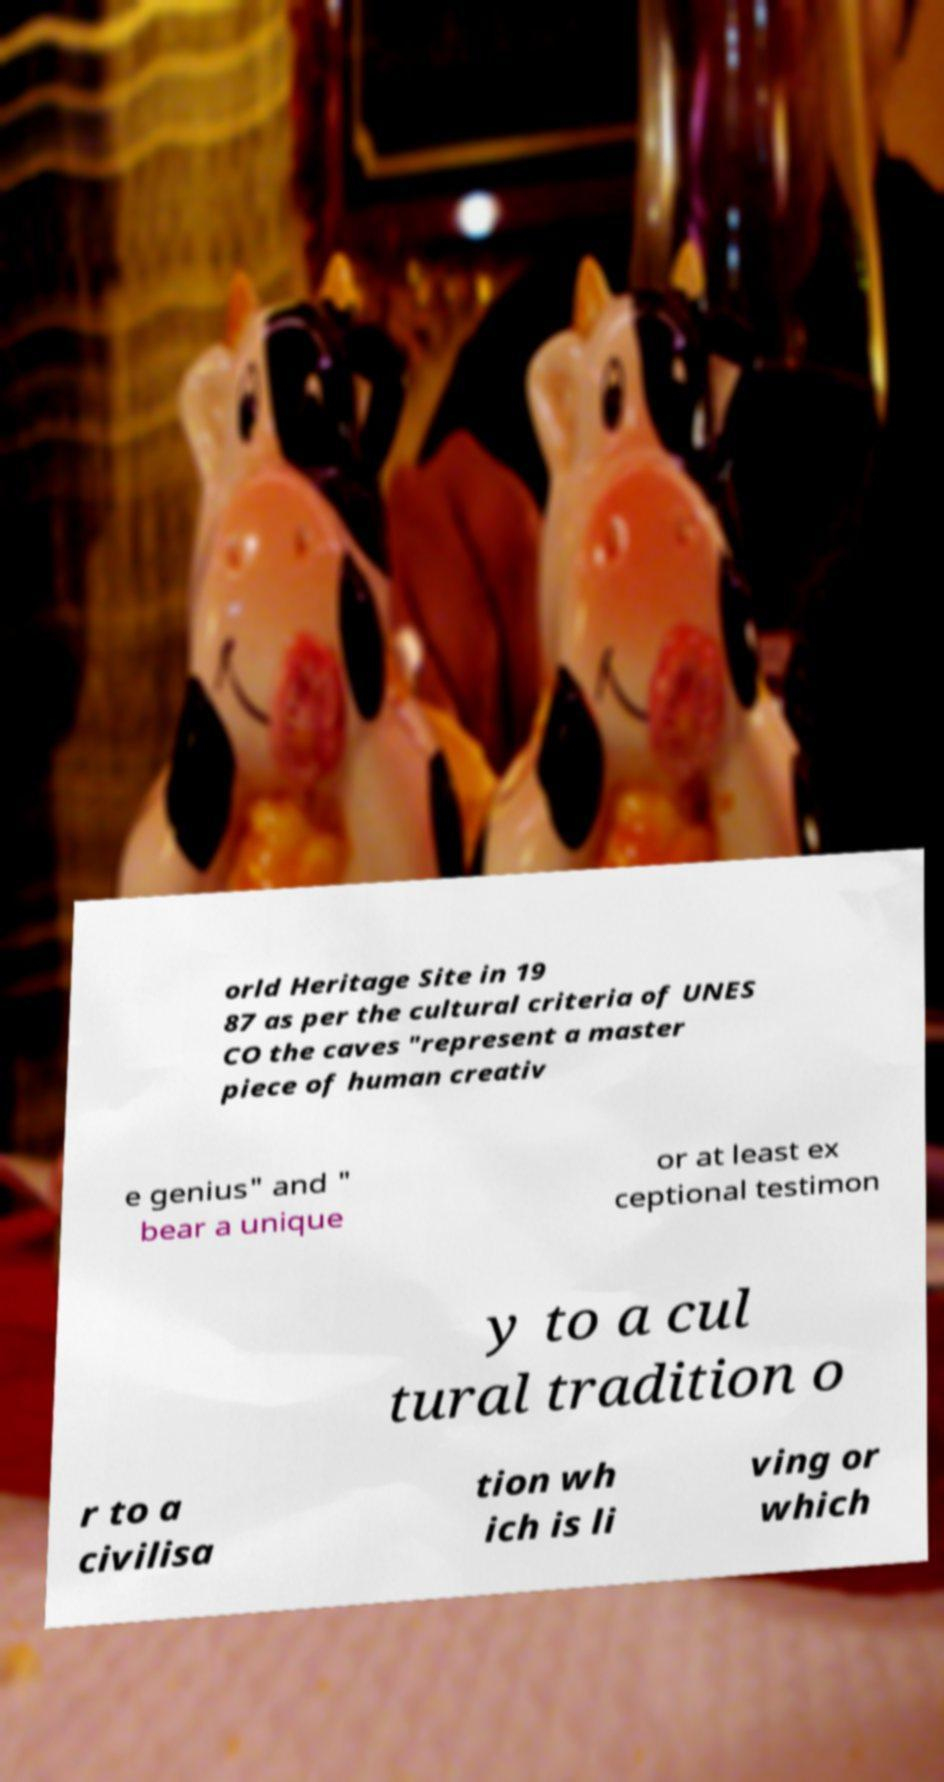Could you extract and type out the text from this image? orld Heritage Site in 19 87 as per the cultural criteria of UNES CO the caves "represent a master piece of human creativ e genius" and " bear a unique or at least ex ceptional testimon y to a cul tural tradition o r to a civilisa tion wh ich is li ving or which 